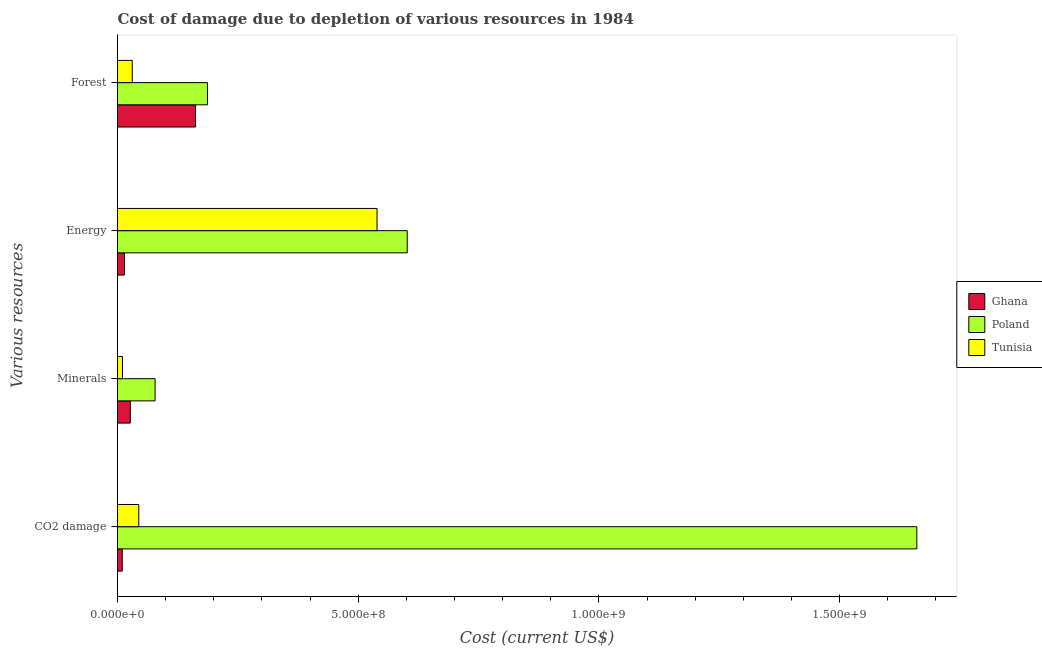Are the number of bars per tick equal to the number of legend labels?
Keep it short and to the point. Yes. What is the label of the 1st group of bars from the top?
Keep it short and to the point. Forest. What is the cost of damage due to depletion of energy in Poland?
Offer a very short reply. 6.02e+08. Across all countries, what is the maximum cost of damage due to depletion of forests?
Your answer should be very brief. 1.87e+08. Across all countries, what is the minimum cost of damage due to depletion of forests?
Provide a succinct answer. 3.06e+07. In which country was the cost of damage due to depletion of energy maximum?
Your answer should be very brief. Poland. In which country was the cost of damage due to depletion of forests minimum?
Make the answer very short. Tunisia. What is the total cost of damage due to depletion of minerals in the graph?
Provide a succinct answer. 1.15e+08. What is the difference between the cost of damage due to depletion of minerals in Poland and that in Tunisia?
Provide a short and direct response. 6.77e+07. What is the difference between the cost of damage due to depletion of energy in Tunisia and the cost of damage due to depletion of coal in Poland?
Ensure brevity in your answer.  -1.12e+09. What is the average cost of damage due to depletion of energy per country?
Keep it short and to the point. 3.85e+08. What is the difference between the cost of damage due to depletion of energy and cost of damage due to depletion of forests in Ghana?
Your response must be concise. -1.48e+08. What is the ratio of the cost of damage due to depletion of coal in Poland to that in Tunisia?
Ensure brevity in your answer.  37.58. What is the difference between the highest and the second highest cost of damage due to depletion of minerals?
Keep it short and to the point. 5.15e+07. What is the difference between the highest and the lowest cost of damage due to depletion of coal?
Offer a very short reply. 1.65e+09. Is the sum of the cost of damage due to depletion of minerals in Tunisia and Ghana greater than the maximum cost of damage due to depletion of coal across all countries?
Keep it short and to the point. No. What does the 1st bar from the top in Minerals represents?
Make the answer very short. Tunisia. What does the 3rd bar from the bottom in Minerals represents?
Your answer should be very brief. Tunisia. Is it the case that in every country, the sum of the cost of damage due to depletion of coal and cost of damage due to depletion of minerals is greater than the cost of damage due to depletion of energy?
Make the answer very short. No. How many countries are there in the graph?
Give a very brief answer. 3. Are the values on the major ticks of X-axis written in scientific E-notation?
Keep it short and to the point. Yes. Does the graph contain any zero values?
Give a very brief answer. No. Does the graph contain grids?
Ensure brevity in your answer.  No. What is the title of the graph?
Keep it short and to the point. Cost of damage due to depletion of various resources in 1984 . Does "Comoros" appear as one of the legend labels in the graph?
Provide a short and direct response. No. What is the label or title of the X-axis?
Make the answer very short. Cost (current US$). What is the label or title of the Y-axis?
Your answer should be compact. Various resources. What is the Cost (current US$) in Ghana in CO2 damage?
Offer a very short reply. 9.88e+06. What is the Cost (current US$) in Poland in CO2 damage?
Your response must be concise. 1.66e+09. What is the Cost (current US$) in Tunisia in CO2 damage?
Provide a short and direct response. 4.42e+07. What is the Cost (current US$) in Ghana in Minerals?
Your answer should be compact. 2.66e+07. What is the Cost (current US$) of Poland in Minerals?
Make the answer very short. 7.81e+07. What is the Cost (current US$) of Tunisia in Minerals?
Offer a terse response. 1.03e+07. What is the Cost (current US$) in Ghana in Energy?
Provide a short and direct response. 1.45e+07. What is the Cost (current US$) in Poland in Energy?
Offer a very short reply. 6.02e+08. What is the Cost (current US$) of Tunisia in Energy?
Provide a short and direct response. 5.39e+08. What is the Cost (current US$) in Ghana in Forest?
Provide a succinct answer. 1.62e+08. What is the Cost (current US$) of Poland in Forest?
Your response must be concise. 1.87e+08. What is the Cost (current US$) of Tunisia in Forest?
Your answer should be very brief. 3.06e+07. Across all Various resources, what is the maximum Cost (current US$) of Ghana?
Your response must be concise. 1.62e+08. Across all Various resources, what is the maximum Cost (current US$) of Poland?
Your answer should be very brief. 1.66e+09. Across all Various resources, what is the maximum Cost (current US$) in Tunisia?
Offer a very short reply. 5.39e+08. Across all Various resources, what is the minimum Cost (current US$) of Ghana?
Offer a terse response. 9.88e+06. Across all Various resources, what is the minimum Cost (current US$) in Poland?
Provide a short and direct response. 7.81e+07. Across all Various resources, what is the minimum Cost (current US$) in Tunisia?
Provide a short and direct response. 1.03e+07. What is the total Cost (current US$) of Ghana in the graph?
Ensure brevity in your answer.  2.13e+08. What is the total Cost (current US$) of Poland in the graph?
Provide a short and direct response. 2.53e+09. What is the total Cost (current US$) in Tunisia in the graph?
Provide a succinct answer. 6.24e+08. What is the difference between the Cost (current US$) of Ghana in CO2 damage and that in Minerals?
Keep it short and to the point. -1.68e+07. What is the difference between the Cost (current US$) of Poland in CO2 damage and that in Minerals?
Ensure brevity in your answer.  1.58e+09. What is the difference between the Cost (current US$) in Tunisia in CO2 damage and that in Minerals?
Ensure brevity in your answer.  3.38e+07. What is the difference between the Cost (current US$) of Ghana in CO2 damage and that in Energy?
Make the answer very short. -4.63e+06. What is the difference between the Cost (current US$) in Poland in CO2 damage and that in Energy?
Provide a succinct answer. 1.06e+09. What is the difference between the Cost (current US$) in Tunisia in CO2 damage and that in Energy?
Offer a very short reply. -4.95e+08. What is the difference between the Cost (current US$) of Ghana in CO2 damage and that in Forest?
Your answer should be very brief. -1.52e+08. What is the difference between the Cost (current US$) in Poland in CO2 damage and that in Forest?
Offer a terse response. 1.47e+09. What is the difference between the Cost (current US$) of Tunisia in CO2 damage and that in Forest?
Keep it short and to the point. 1.36e+07. What is the difference between the Cost (current US$) in Ghana in Minerals and that in Energy?
Offer a terse response. 1.21e+07. What is the difference between the Cost (current US$) in Poland in Minerals and that in Energy?
Offer a very short reply. -5.24e+08. What is the difference between the Cost (current US$) of Tunisia in Minerals and that in Energy?
Provide a short and direct response. -5.29e+08. What is the difference between the Cost (current US$) in Ghana in Minerals and that in Forest?
Provide a short and direct response. -1.35e+08. What is the difference between the Cost (current US$) of Poland in Minerals and that in Forest?
Offer a very short reply. -1.09e+08. What is the difference between the Cost (current US$) of Tunisia in Minerals and that in Forest?
Offer a very short reply. -2.03e+07. What is the difference between the Cost (current US$) of Ghana in Energy and that in Forest?
Provide a succinct answer. -1.48e+08. What is the difference between the Cost (current US$) in Poland in Energy and that in Forest?
Make the answer very short. 4.15e+08. What is the difference between the Cost (current US$) of Tunisia in Energy and that in Forest?
Your answer should be very brief. 5.09e+08. What is the difference between the Cost (current US$) of Ghana in CO2 damage and the Cost (current US$) of Poland in Minerals?
Give a very brief answer. -6.82e+07. What is the difference between the Cost (current US$) of Ghana in CO2 damage and the Cost (current US$) of Tunisia in Minerals?
Offer a very short reply. -4.67e+05. What is the difference between the Cost (current US$) in Poland in CO2 damage and the Cost (current US$) in Tunisia in Minerals?
Your answer should be very brief. 1.65e+09. What is the difference between the Cost (current US$) in Ghana in CO2 damage and the Cost (current US$) in Poland in Energy?
Your answer should be compact. -5.92e+08. What is the difference between the Cost (current US$) of Ghana in CO2 damage and the Cost (current US$) of Tunisia in Energy?
Provide a short and direct response. -5.29e+08. What is the difference between the Cost (current US$) in Poland in CO2 damage and the Cost (current US$) in Tunisia in Energy?
Give a very brief answer. 1.12e+09. What is the difference between the Cost (current US$) in Ghana in CO2 damage and the Cost (current US$) in Poland in Forest?
Give a very brief answer. -1.77e+08. What is the difference between the Cost (current US$) in Ghana in CO2 damage and the Cost (current US$) in Tunisia in Forest?
Your response must be concise. -2.07e+07. What is the difference between the Cost (current US$) in Poland in CO2 damage and the Cost (current US$) in Tunisia in Forest?
Provide a succinct answer. 1.63e+09. What is the difference between the Cost (current US$) in Ghana in Minerals and the Cost (current US$) in Poland in Energy?
Keep it short and to the point. -5.75e+08. What is the difference between the Cost (current US$) in Ghana in Minerals and the Cost (current US$) in Tunisia in Energy?
Keep it short and to the point. -5.13e+08. What is the difference between the Cost (current US$) of Poland in Minerals and the Cost (current US$) of Tunisia in Energy?
Keep it short and to the point. -4.61e+08. What is the difference between the Cost (current US$) in Ghana in Minerals and the Cost (current US$) in Poland in Forest?
Make the answer very short. -1.60e+08. What is the difference between the Cost (current US$) of Ghana in Minerals and the Cost (current US$) of Tunisia in Forest?
Provide a short and direct response. -3.98e+06. What is the difference between the Cost (current US$) in Poland in Minerals and the Cost (current US$) in Tunisia in Forest?
Your answer should be very brief. 4.75e+07. What is the difference between the Cost (current US$) in Ghana in Energy and the Cost (current US$) in Poland in Forest?
Offer a terse response. -1.72e+08. What is the difference between the Cost (current US$) of Ghana in Energy and the Cost (current US$) of Tunisia in Forest?
Ensure brevity in your answer.  -1.61e+07. What is the difference between the Cost (current US$) in Poland in Energy and the Cost (current US$) in Tunisia in Forest?
Ensure brevity in your answer.  5.71e+08. What is the average Cost (current US$) of Ghana per Various resources?
Keep it short and to the point. 5.33e+07. What is the average Cost (current US$) of Poland per Various resources?
Your answer should be very brief. 6.32e+08. What is the average Cost (current US$) in Tunisia per Various resources?
Your response must be concise. 1.56e+08. What is the difference between the Cost (current US$) in Ghana and Cost (current US$) in Poland in CO2 damage?
Provide a short and direct response. -1.65e+09. What is the difference between the Cost (current US$) of Ghana and Cost (current US$) of Tunisia in CO2 damage?
Make the answer very short. -3.43e+07. What is the difference between the Cost (current US$) of Poland and Cost (current US$) of Tunisia in CO2 damage?
Provide a succinct answer. 1.62e+09. What is the difference between the Cost (current US$) of Ghana and Cost (current US$) of Poland in Minerals?
Your answer should be compact. -5.15e+07. What is the difference between the Cost (current US$) of Ghana and Cost (current US$) of Tunisia in Minerals?
Provide a short and direct response. 1.63e+07. What is the difference between the Cost (current US$) of Poland and Cost (current US$) of Tunisia in Minerals?
Offer a terse response. 6.77e+07. What is the difference between the Cost (current US$) in Ghana and Cost (current US$) in Poland in Energy?
Offer a terse response. -5.87e+08. What is the difference between the Cost (current US$) in Ghana and Cost (current US$) in Tunisia in Energy?
Your response must be concise. -5.25e+08. What is the difference between the Cost (current US$) in Poland and Cost (current US$) in Tunisia in Energy?
Your answer should be compact. 6.27e+07. What is the difference between the Cost (current US$) in Ghana and Cost (current US$) in Poland in Forest?
Your response must be concise. -2.47e+07. What is the difference between the Cost (current US$) of Ghana and Cost (current US$) of Tunisia in Forest?
Offer a terse response. 1.31e+08. What is the difference between the Cost (current US$) in Poland and Cost (current US$) in Tunisia in Forest?
Your response must be concise. 1.56e+08. What is the ratio of the Cost (current US$) in Ghana in CO2 damage to that in Minerals?
Make the answer very short. 0.37. What is the ratio of the Cost (current US$) of Poland in CO2 damage to that in Minerals?
Offer a very short reply. 21.26. What is the ratio of the Cost (current US$) in Tunisia in CO2 damage to that in Minerals?
Provide a succinct answer. 4.27. What is the ratio of the Cost (current US$) in Ghana in CO2 damage to that in Energy?
Ensure brevity in your answer.  0.68. What is the ratio of the Cost (current US$) of Poland in CO2 damage to that in Energy?
Ensure brevity in your answer.  2.76. What is the ratio of the Cost (current US$) in Tunisia in CO2 damage to that in Energy?
Ensure brevity in your answer.  0.08. What is the ratio of the Cost (current US$) of Ghana in CO2 damage to that in Forest?
Give a very brief answer. 0.06. What is the ratio of the Cost (current US$) of Poland in CO2 damage to that in Forest?
Provide a short and direct response. 8.89. What is the ratio of the Cost (current US$) of Tunisia in CO2 damage to that in Forest?
Your response must be concise. 1.44. What is the ratio of the Cost (current US$) of Ghana in Minerals to that in Energy?
Ensure brevity in your answer.  1.84. What is the ratio of the Cost (current US$) in Poland in Minerals to that in Energy?
Make the answer very short. 0.13. What is the ratio of the Cost (current US$) of Tunisia in Minerals to that in Energy?
Offer a terse response. 0.02. What is the ratio of the Cost (current US$) in Ghana in Minerals to that in Forest?
Provide a succinct answer. 0.16. What is the ratio of the Cost (current US$) in Poland in Minerals to that in Forest?
Provide a succinct answer. 0.42. What is the ratio of the Cost (current US$) in Tunisia in Minerals to that in Forest?
Provide a short and direct response. 0.34. What is the ratio of the Cost (current US$) of Ghana in Energy to that in Forest?
Your answer should be very brief. 0.09. What is the ratio of the Cost (current US$) in Poland in Energy to that in Forest?
Your answer should be very brief. 3.22. What is the ratio of the Cost (current US$) in Tunisia in Energy to that in Forest?
Give a very brief answer. 17.61. What is the difference between the highest and the second highest Cost (current US$) of Ghana?
Your response must be concise. 1.35e+08. What is the difference between the highest and the second highest Cost (current US$) of Poland?
Make the answer very short. 1.06e+09. What is the difference between the highest and the second highest Cost (current US$) of Tunisia?
Offer a terse response. 4.95e+08. What is the difference between the highest and the lowest Cost (current US$) of Ghana?
Give a very brief answer. 1.52e+08. What is the difference between the highest and the lowest Cost (current US$) in Poland?
Ensure brevity in your answer.  1.58e+09. What is the difference between the highest and the lowest Cost (current US$) of Tunisia?
Your response must be concise. 5.29e+08. 